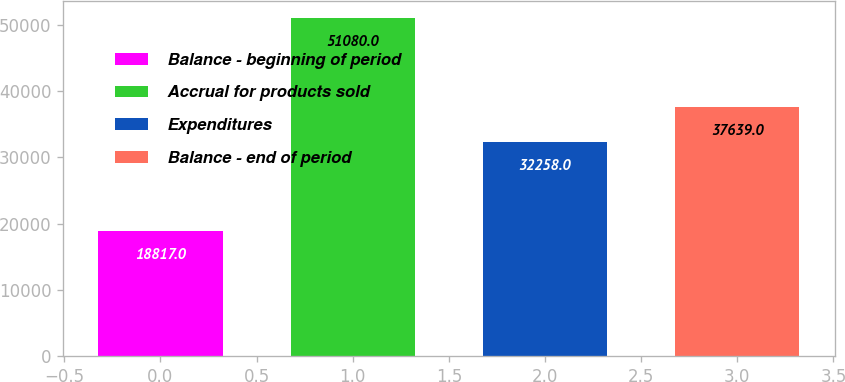Convert chart to OTSL. <chart><loc_0><loc_0><loc_500><loc_500><bar_chart><fcel>Balance - beginning of period<fcel>Accrual for products sold<fcel>Expenditures<fcel>Balance - end of period<nl><fcel>18817<fcel>51080<fcel>32258<fcel>37639<nl></chart> 